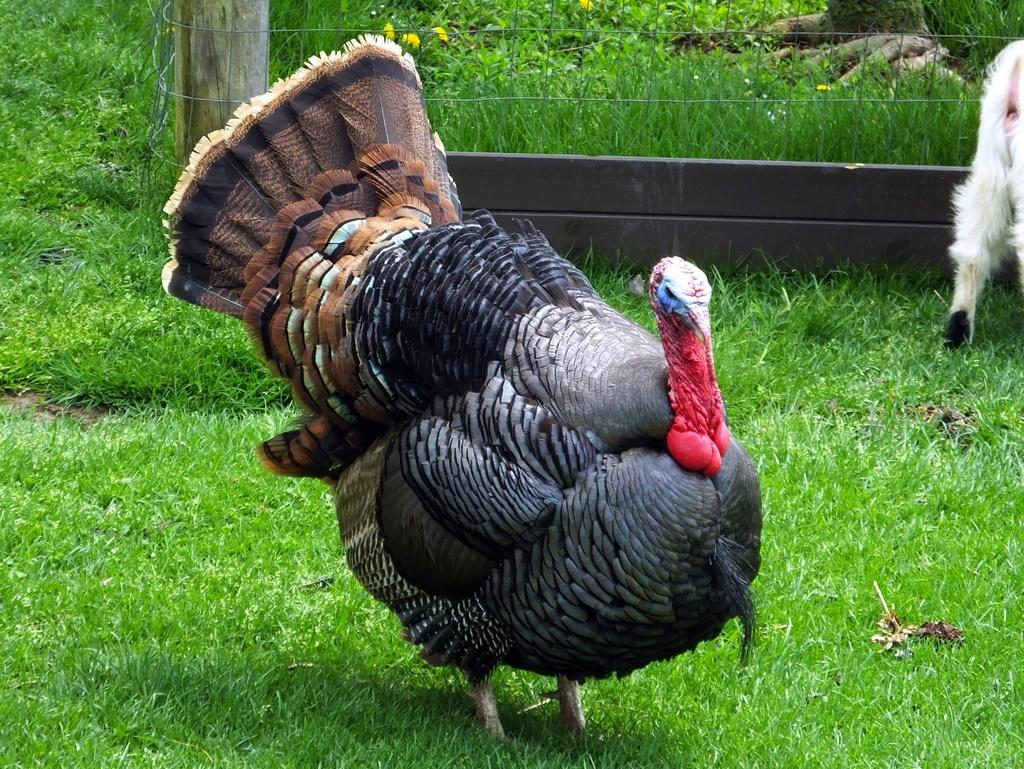What is on the ground in the image? There is a bird on the ground in the image. What type of vegetation is on the ground? The ground has grass on it. What can be seen in the background of the image? There is a white color animal near a fence and a tree visible in the background of the image. What is the health status of the tank in the image? There is no tank present in the image, so it is not possible to determine its health status. 